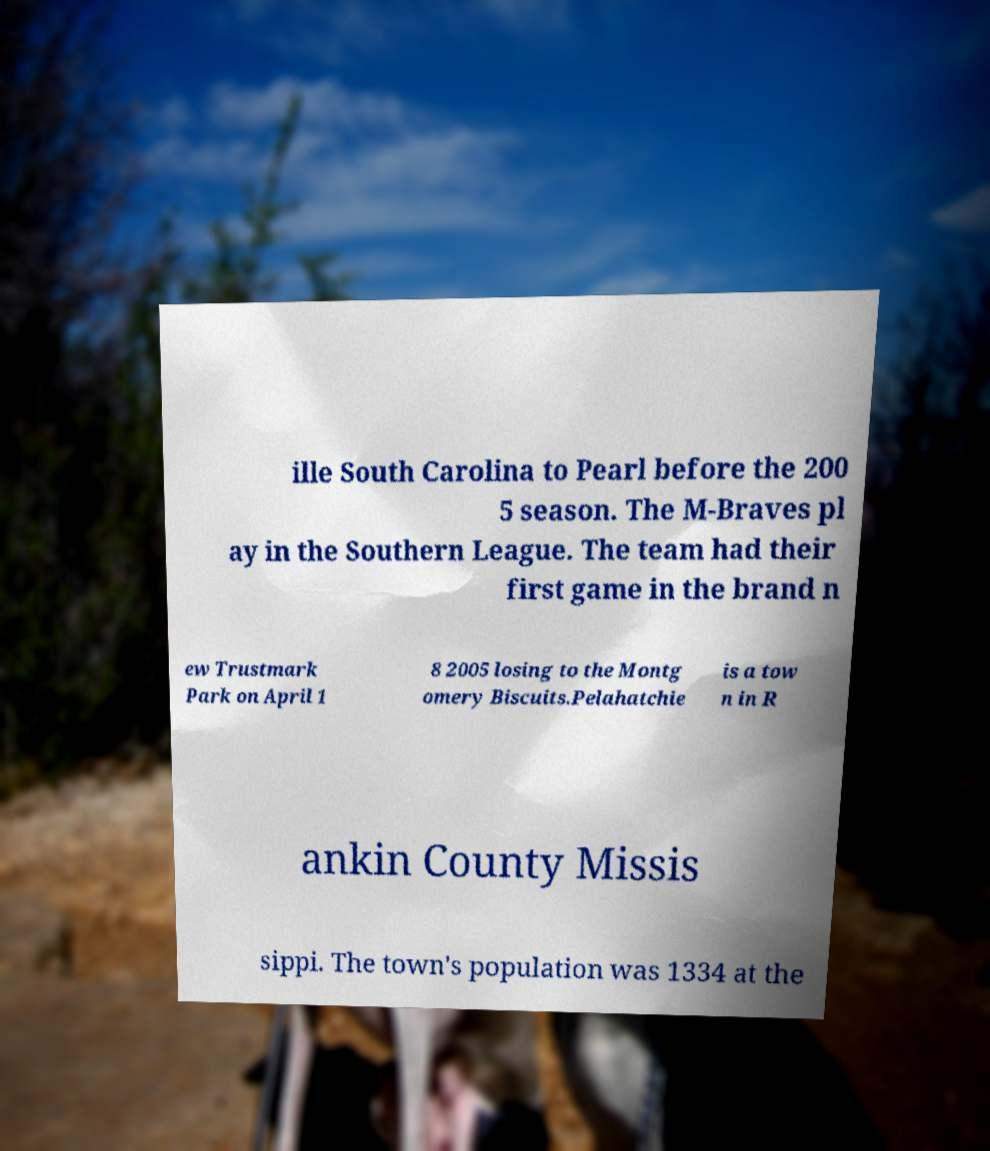Could you extract and type out the text from this image? ille South Carolina to Pearl before the 200 5 season. The M-Braves pl ay in the Southern League. The team had their first game in the brand n ew Trustmark Park on April 1 8 2005 losing to the Montg omery Biscuits.Pelahatchie is a tow n in R ankin County Missis sippi. The town's population was 1334 at the 